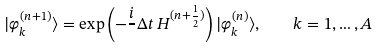Convert formula to latex. <formula><loc_0><loc_0><loc_500><loc_500>| \varphi _ { k } ^ { ( n + 1 ) } \rangle = \exp \left ( - \frac { i } { } \Delta t \, H ^ { ( n + \frac { 1 } { 2 } ) } \right ) | \varphi _ { k } ^ { ( n ) } \rangle , \quad k = 1 , \dots , A</formula> 